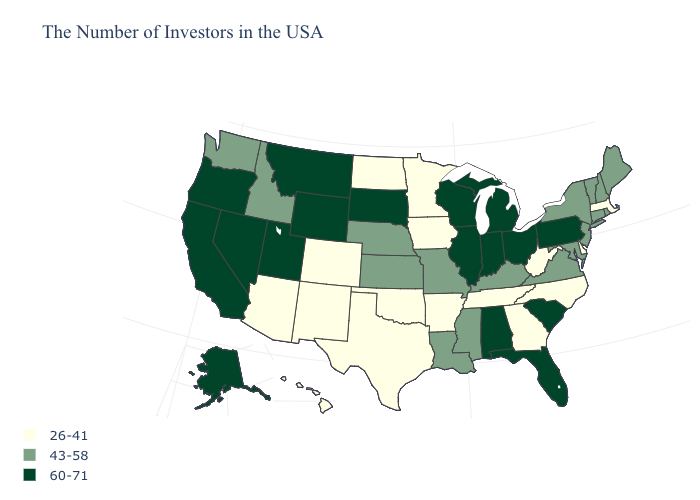What is the value of Washington?
Give a very brief answer. 43-58. How many symbols are there in the legend?
Be succinct. 3. Does New York have the lowest value in the Northeast?
Keep it brief. No. Is the legend a continuous bar?
Write a very short answer. No. What is the value of Pennsylvania?
Short answer required. 60-71. Among the states that border Missouri , does Illinois have the lowest value?
Quick response, please. No. What is the highest value in the MidWest ?
Short answer required. 60-71. What is the value of Kansas?
Be succinct. 43-58. What is the lowest value in states that border Wyoming?
Quick response, please. 26-41. Among the states that border Indiana , which have the highest value?
Answer briefly. Ohio, Michigan, Illinois. Name the states that have a value in the range 26-41?
Keep it brief. Massachusetts, Delaware, North Carolina, West Virginia, Georgia, Tennessee, Arkansas, Minnesota, Iowa, Oklahoma, Texas, North Dakota, Colorado, New Mexico, Arizona, Hawaii. What is the lowest value in the Northeast?
Quick response, please. 26-41. Does Washington have a higher value than West Virginia?
Write a very short answer. Yes. What is the value of Rhode Island?
Keep it brief. 43-58. What is the lowest value in the South?
Be succinct. 26-41. 